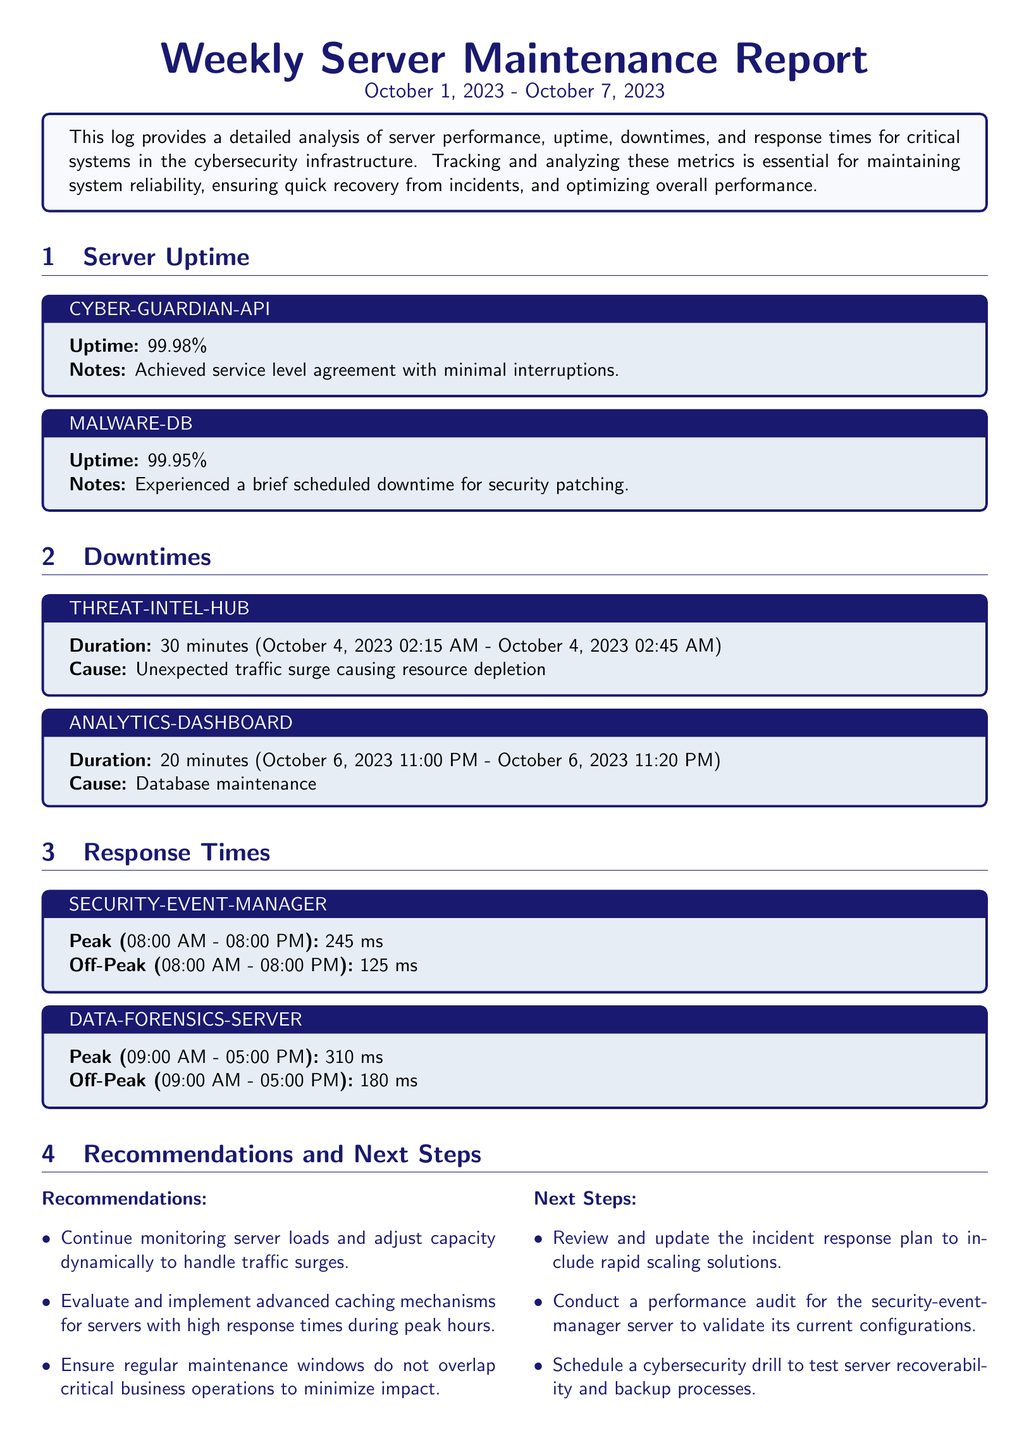What is the uptime percentage for CYBER-GUARDIAN-API? The uptime percentage for CYBER-GUARDIAN-API is specifically listed in the document, which states it achieved 99.98%.
Answer: 99.98% What caused the downtime for THREAT-INTEL-HUB? The document specifies that the cause of downtime for THREAT-INTEL-HUB was an unexpected traffic surge causing resource depletion.
Answer: Unexpected traffic surge causing resource depletion During what hours did the SECURITY-EVENT-MANAGER record its response times? The hours for the SECURITY-EVENT-MANAGER's response times are indicated in the document, stating it is from 08:00 AM to 08:00 PM.
Answer: 08:00 AM - 08:00 PM What is the total downtime duration for ANALYTICS-DASHBOARD? The document provides specific downtime details for ANALYTICS-DASHBOARD, which lasted for 20 minutes.
Answer: 20 minutes What is one of the recommendations listed in the report? The document includes various recommendations, one of which is about monitoring server loads.
Answer: Continue monitoring server loads What was the peak response time for DATA-FORENSICS-SERVER? The peak response time for DATA-FORENSICS-SERVER is detailed in the document, specifically noted as 310 milliseconds.
Answer: 310 ms What is the date range covered by this weekly report? The date range for the report is clearly provided at the beginning, from October 1, 2023 to October 7, 2023.
Answer: October 1, 2023 - October 7, 2023 What is one of the next steps mentioned in the report? The document states several next steps, one of which includes reviewing and updating the incident response plan.
Answer: Review and update the incident response plan 